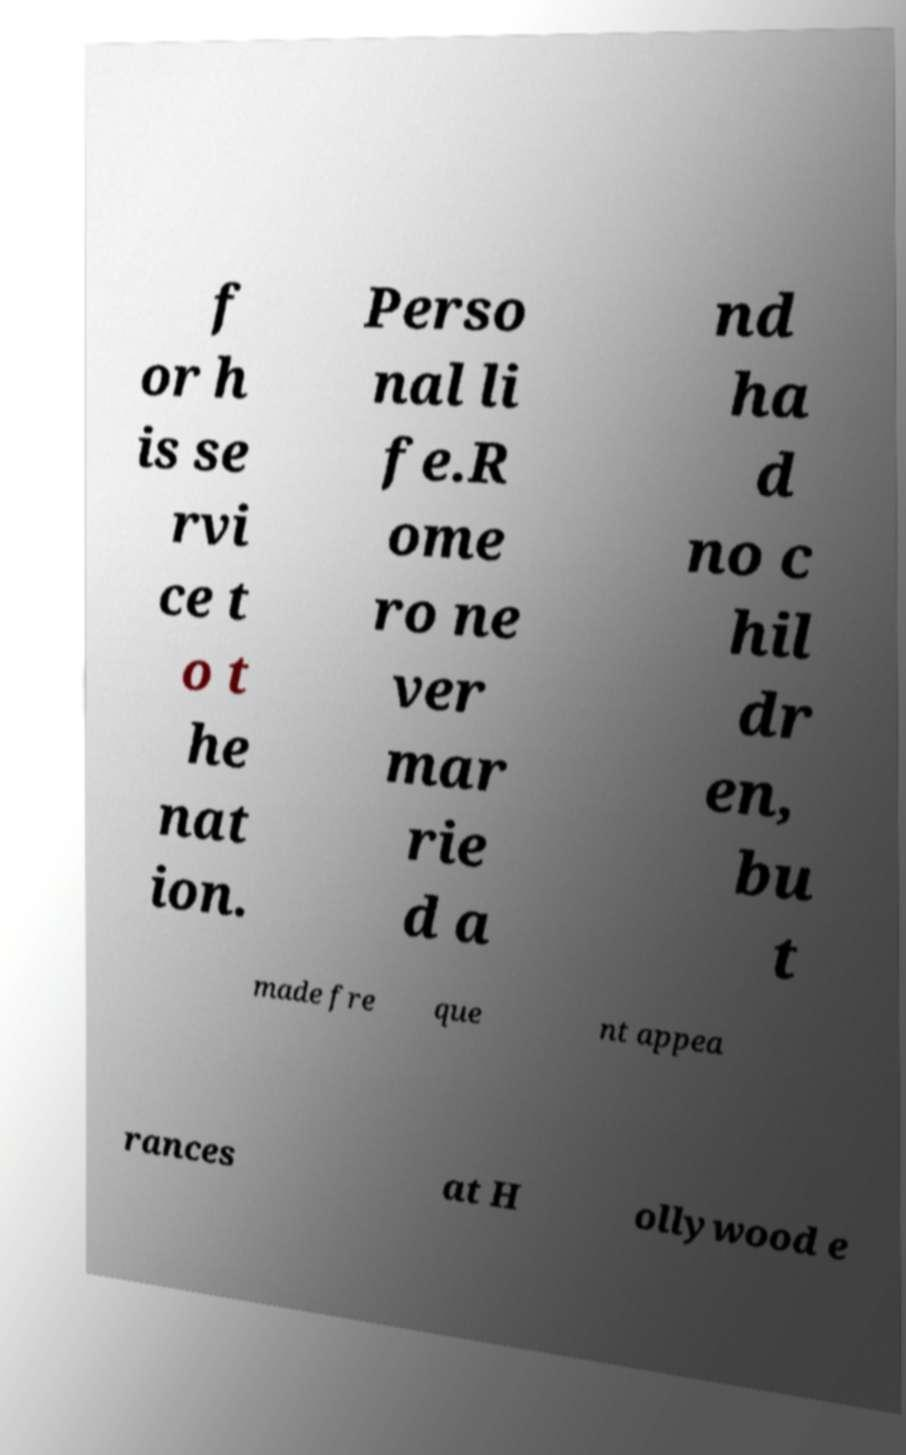Please identify and transcribe the text found in this image. f or h is se rvi ce t o t he nat ion. Perso nal li fe.R ome ro ne ver mar rie d a nd ha d no c hil dr en, bu t made fre que nt appea rances at H ollywood e 